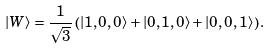<formula> <loc_0><loc_0><loc_500><loc_500>| W \rangle = \frac { 1 } { \sqrt { 3 } } \left ( | 1 , 0 , 0 \rangle + | 0 , 1 , 0 \rangle + | 0 , 0 , 1 \rangle \right ) .</formula> 